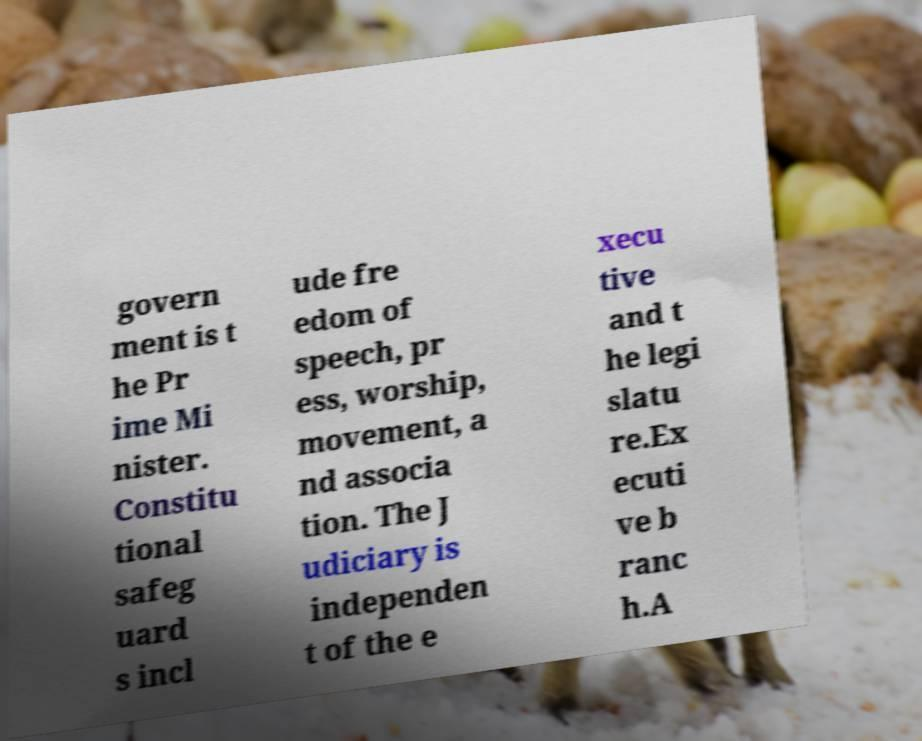What messages or text are displayed in this image? I need them in a readable, typed format. govern ment is t he Pr ime Mi nister. Constitu tional safeg uard s incl ude fre edom of speech, pr ess, worship, movement, a nd associa tion. The J udiciary is independen t of the e xecu tive and t he legi slatu re.Ex ecuti ve b ranc h.A 